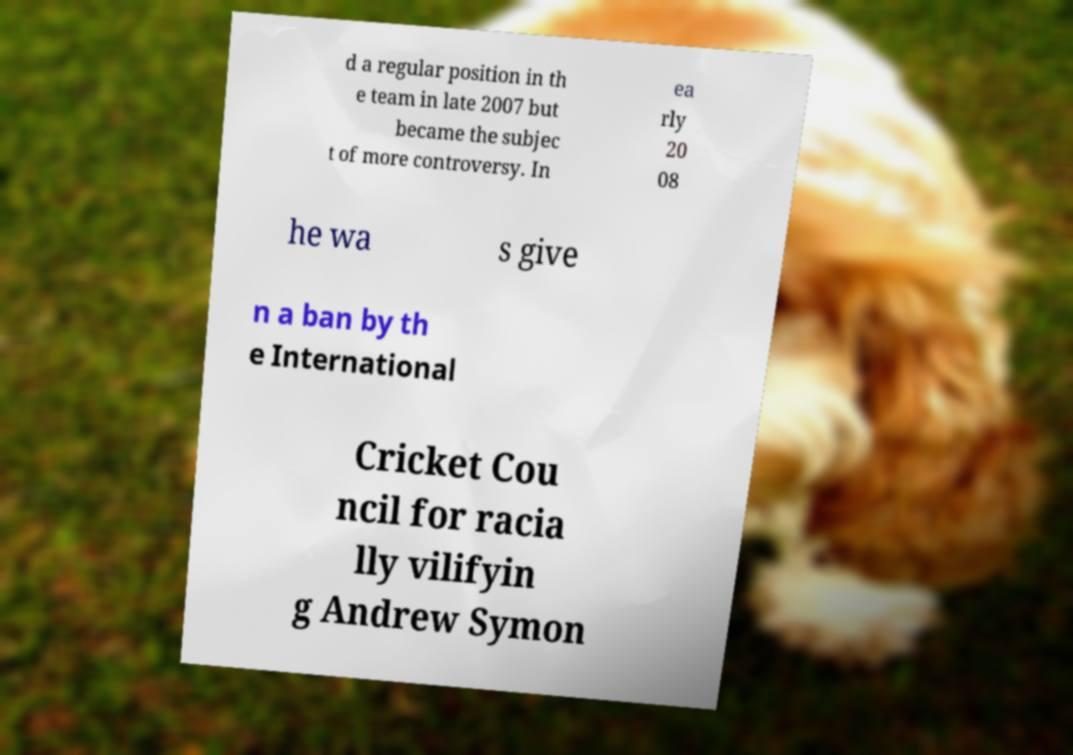What messages or text are displayed in this image? I need them in a readable, typed format. d a regular position in th e team in late 2007 but became the subjec t of more controversy. In ea rly 20 08 he wa s give n a ban by th e International Cricket Cou ncil for racia lly vilifyin g Andrew Symon 